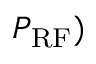<formula> <loc_0><loc_0><loc_500><loc_500>P _ { R F } )</formula> 